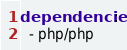Convert code to text. <code><loc_0><loc_0><loc_500><loc_500><_YAML_>dependencies:
  - php/php
</code> 